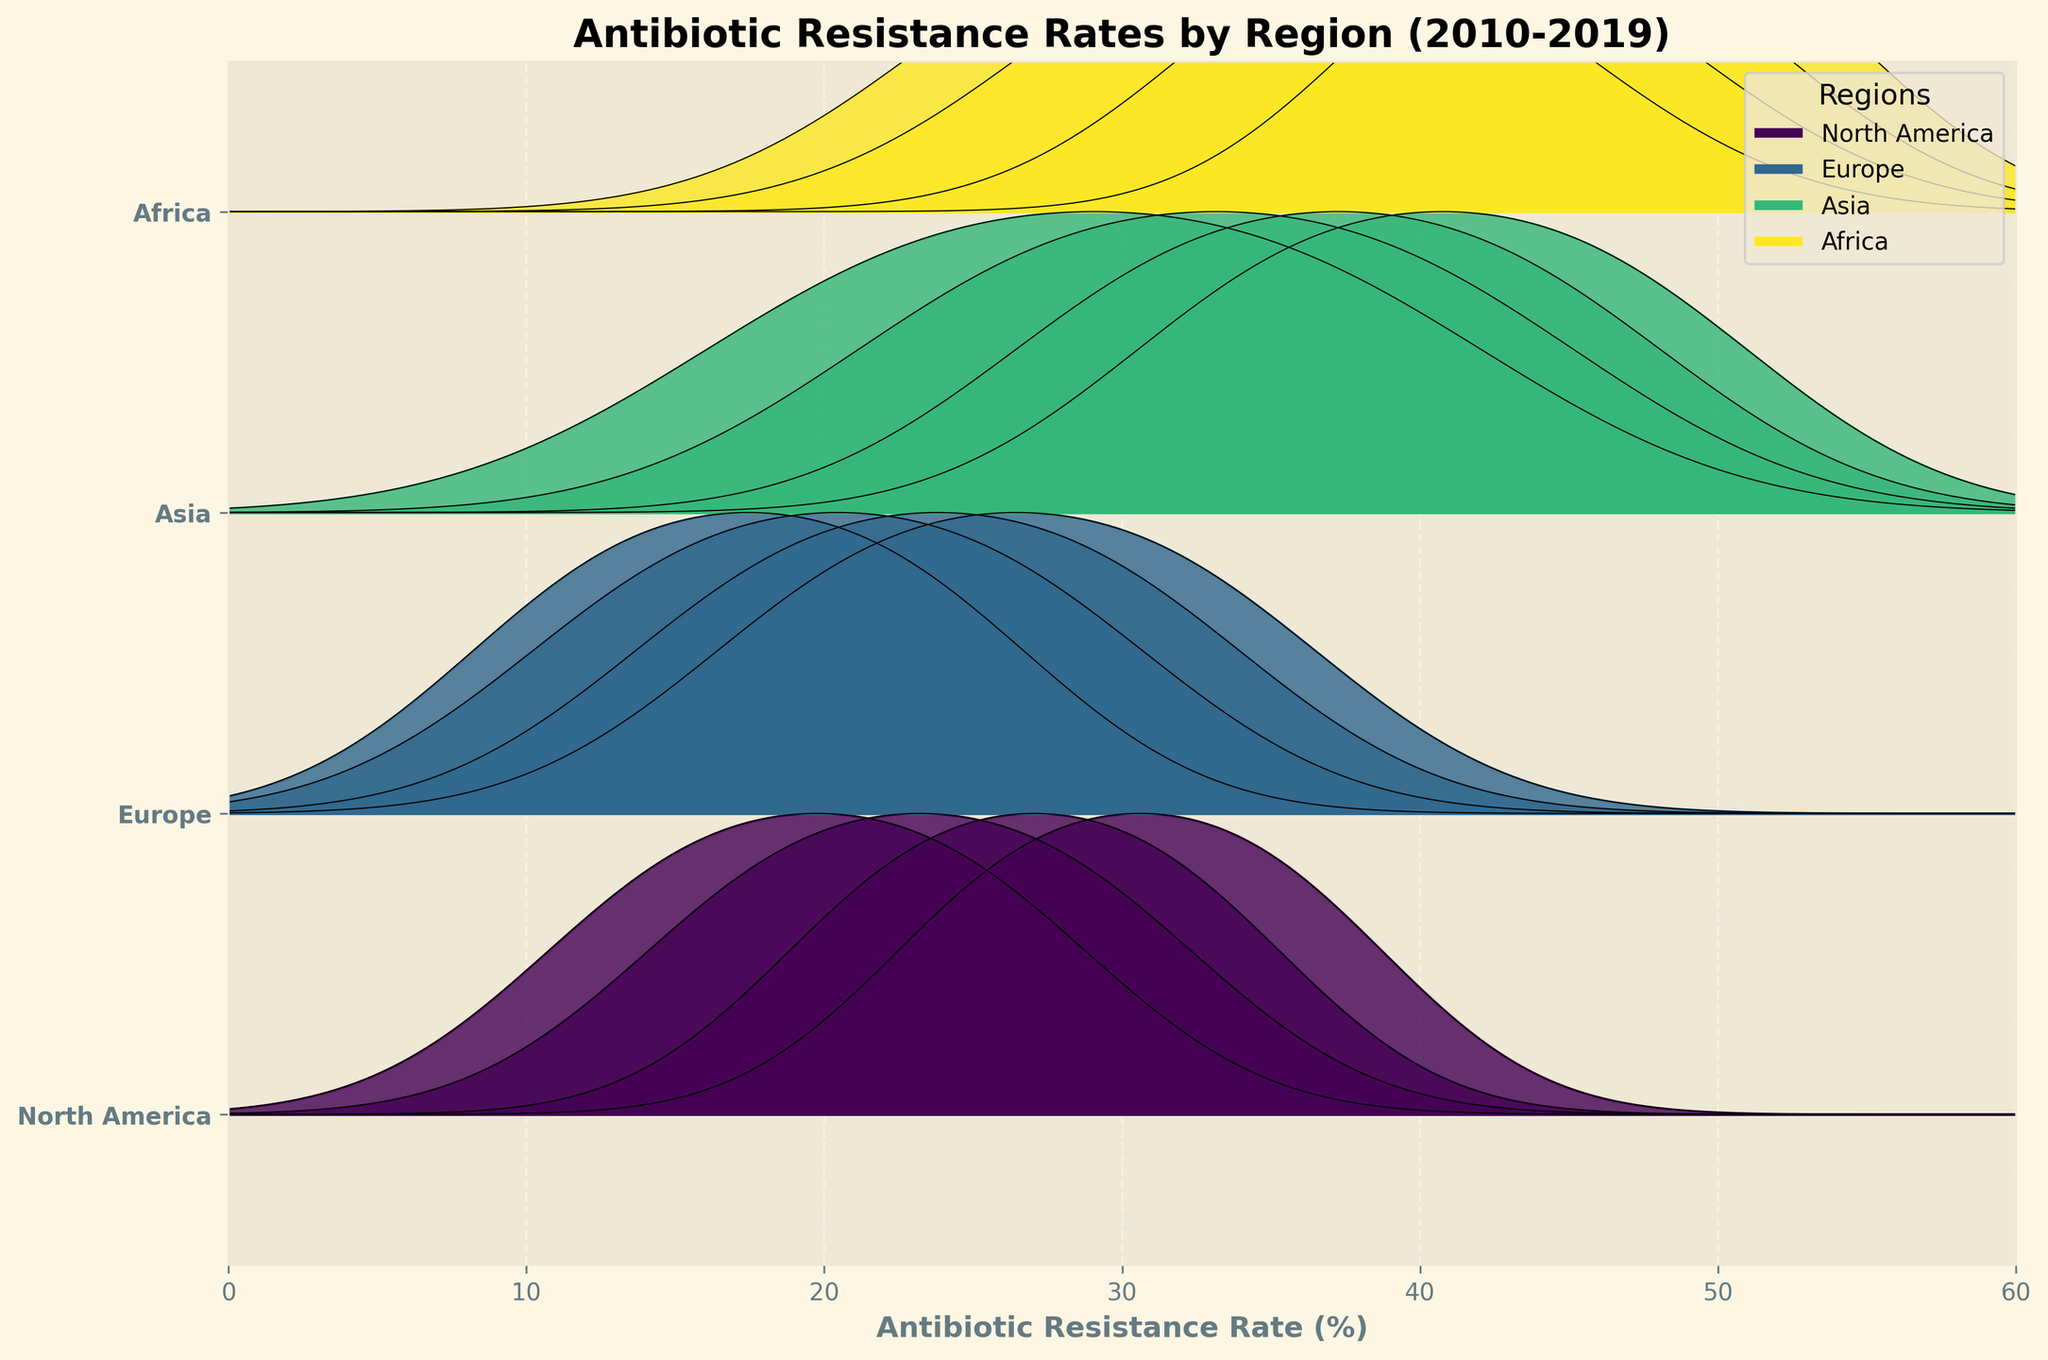What is the title of the figure? The title is usually located at the top of the figure and is prominently displayed with a larger font size compared to other text.
Answer: Antibiotic Resistance Rates by Region (2010-2019) Which region's antibiotic resistance rates are highest on average? By examining the heights of the ridgelines across different regions, the Africa region consistently has higher ridgelines, indicating higher antibiotic resistance rates.
Answer: Africa How many regions are displayed in the figure? The y-axis lists the regions, which can be counted directly.
Answer: Four Which year has the highest antibiotic resistance rate for Escherichia coli in Asia? By inspecting the peaks of the ridgelines for the Asia region over the years, the highest peak corresponds to 2019.
Answer: 2019 How does the trend of Staphylococcus aureus resistance rates in Europe change over time? By examining the ridgelines for Europe over the years, the ridgelines gradually rise, indicating an increase in resistance rates over time.
Answer: Increasing What is the range of antibiotic resistance rates displayed on the x-axis? The x-axis labels indicate the minimum and maximum values covered in the graph.
Answer: 0 to 60 Compare the resistance rate trends of Escherichia coli in North America and Africa from 2010 to 2019. By following the ridgelines for both regions, Escherichia coli resistance rates in North America increase steadily, while in Africa, the rates are consistently higher and also increase over time.
Answer: Both increase; Africa has higher rates What is the relative position of North America in terms of antibiotic resistance? The North America region ridgeline is consistently lower than Africa and Asia but higher than Europe, putting it in the middle range.
Answer: Middle range Is there a year when Europe shows a significant rise in resistance rates for any pathogen? Europe shows a noticeable rise in ridgelines from 2016 onwards, indicating increased resistance rates compared to earlier years.
Answer: 2016 By 2019, which region has the lowest antibiotic resistance rates for Staphylococcus aureus? By checking the 2019 ridgelines for Staphylococcus aureus across regions, North America's ridgeline is the lowest.
Answer: North America 